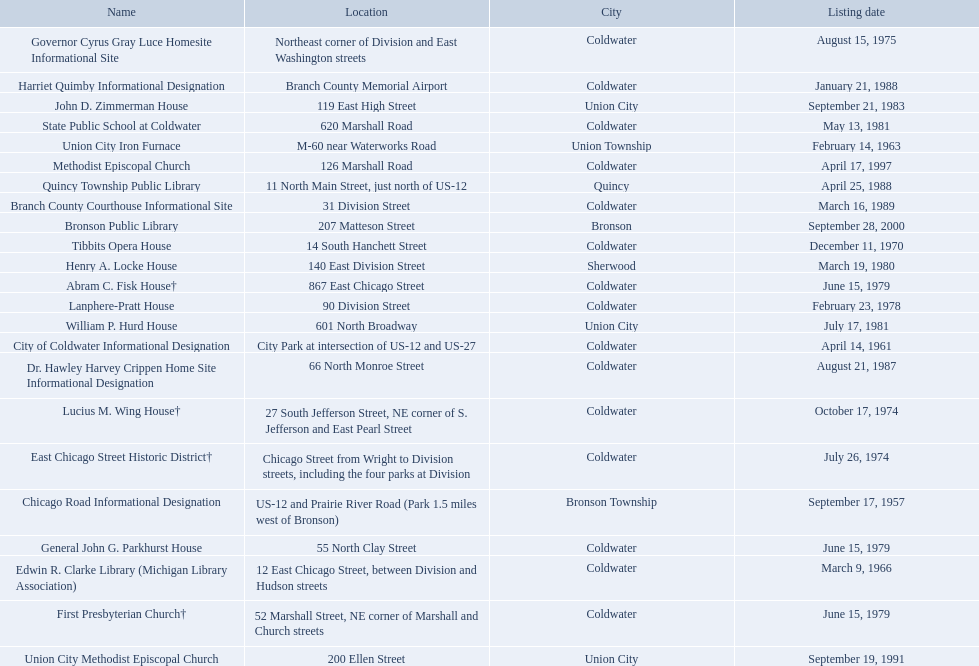In branch co. mi what historic sites are located on a near a highway? Chicago Road Informational Designation, City of Coldwater Informational Designation, Quincy Township Public Library, Union City Iron Furnace. Of the historic sites ins branch co. near highways, which ones are near only us highways? Chicago Road Informational Designation, City of Coldwater Informational Designation, Quincy Township Public Library. Which historical sites in branch co. are near only us highways and are not a building? Chicago Road Informational Designation, City of Coldwater Informational Designation. Which non-building historical sites in branch county near a us highways is closest to bronson? Chicago Road Informational Designation. 